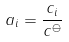Convert formula to latex. <formula><loc_0><loc_0><loc_500><loc_500>a _ { i } = \frac { c _ { i } } { c ^ { \ominus } }</formula> 